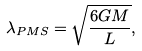Convert formula to latex. <formula><loc_0><loc_0><loc_500><loc_500>\lambda _ { P M S } = \sqrt { \frac { 6 G M } { L } } ,</formula> 